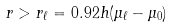<formula> <loc_0><loc_0><loc_500><loc_500>r > r _ { \ell } = 0 . 9 2 h ( \mu _ { \ell } - \mu _ { 0 } )</formula> 